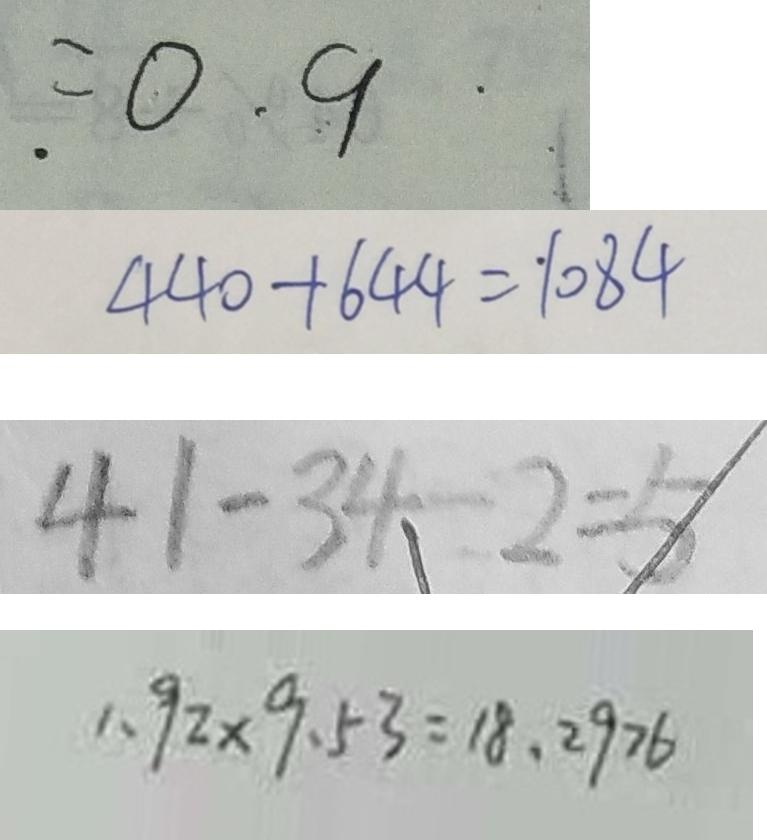Convert formula to latex. <formula><loc_0><loc_0><loc_500><loc_500>= 0 . 9 
 4 4 0 + 6 4 4 = 1 0 8 4 
 4 1 - 3 4 - 2 = 5 
 1 . 9 2 \times 9 . 5 3 = 1 8 . 2 9 7 6</formula> 